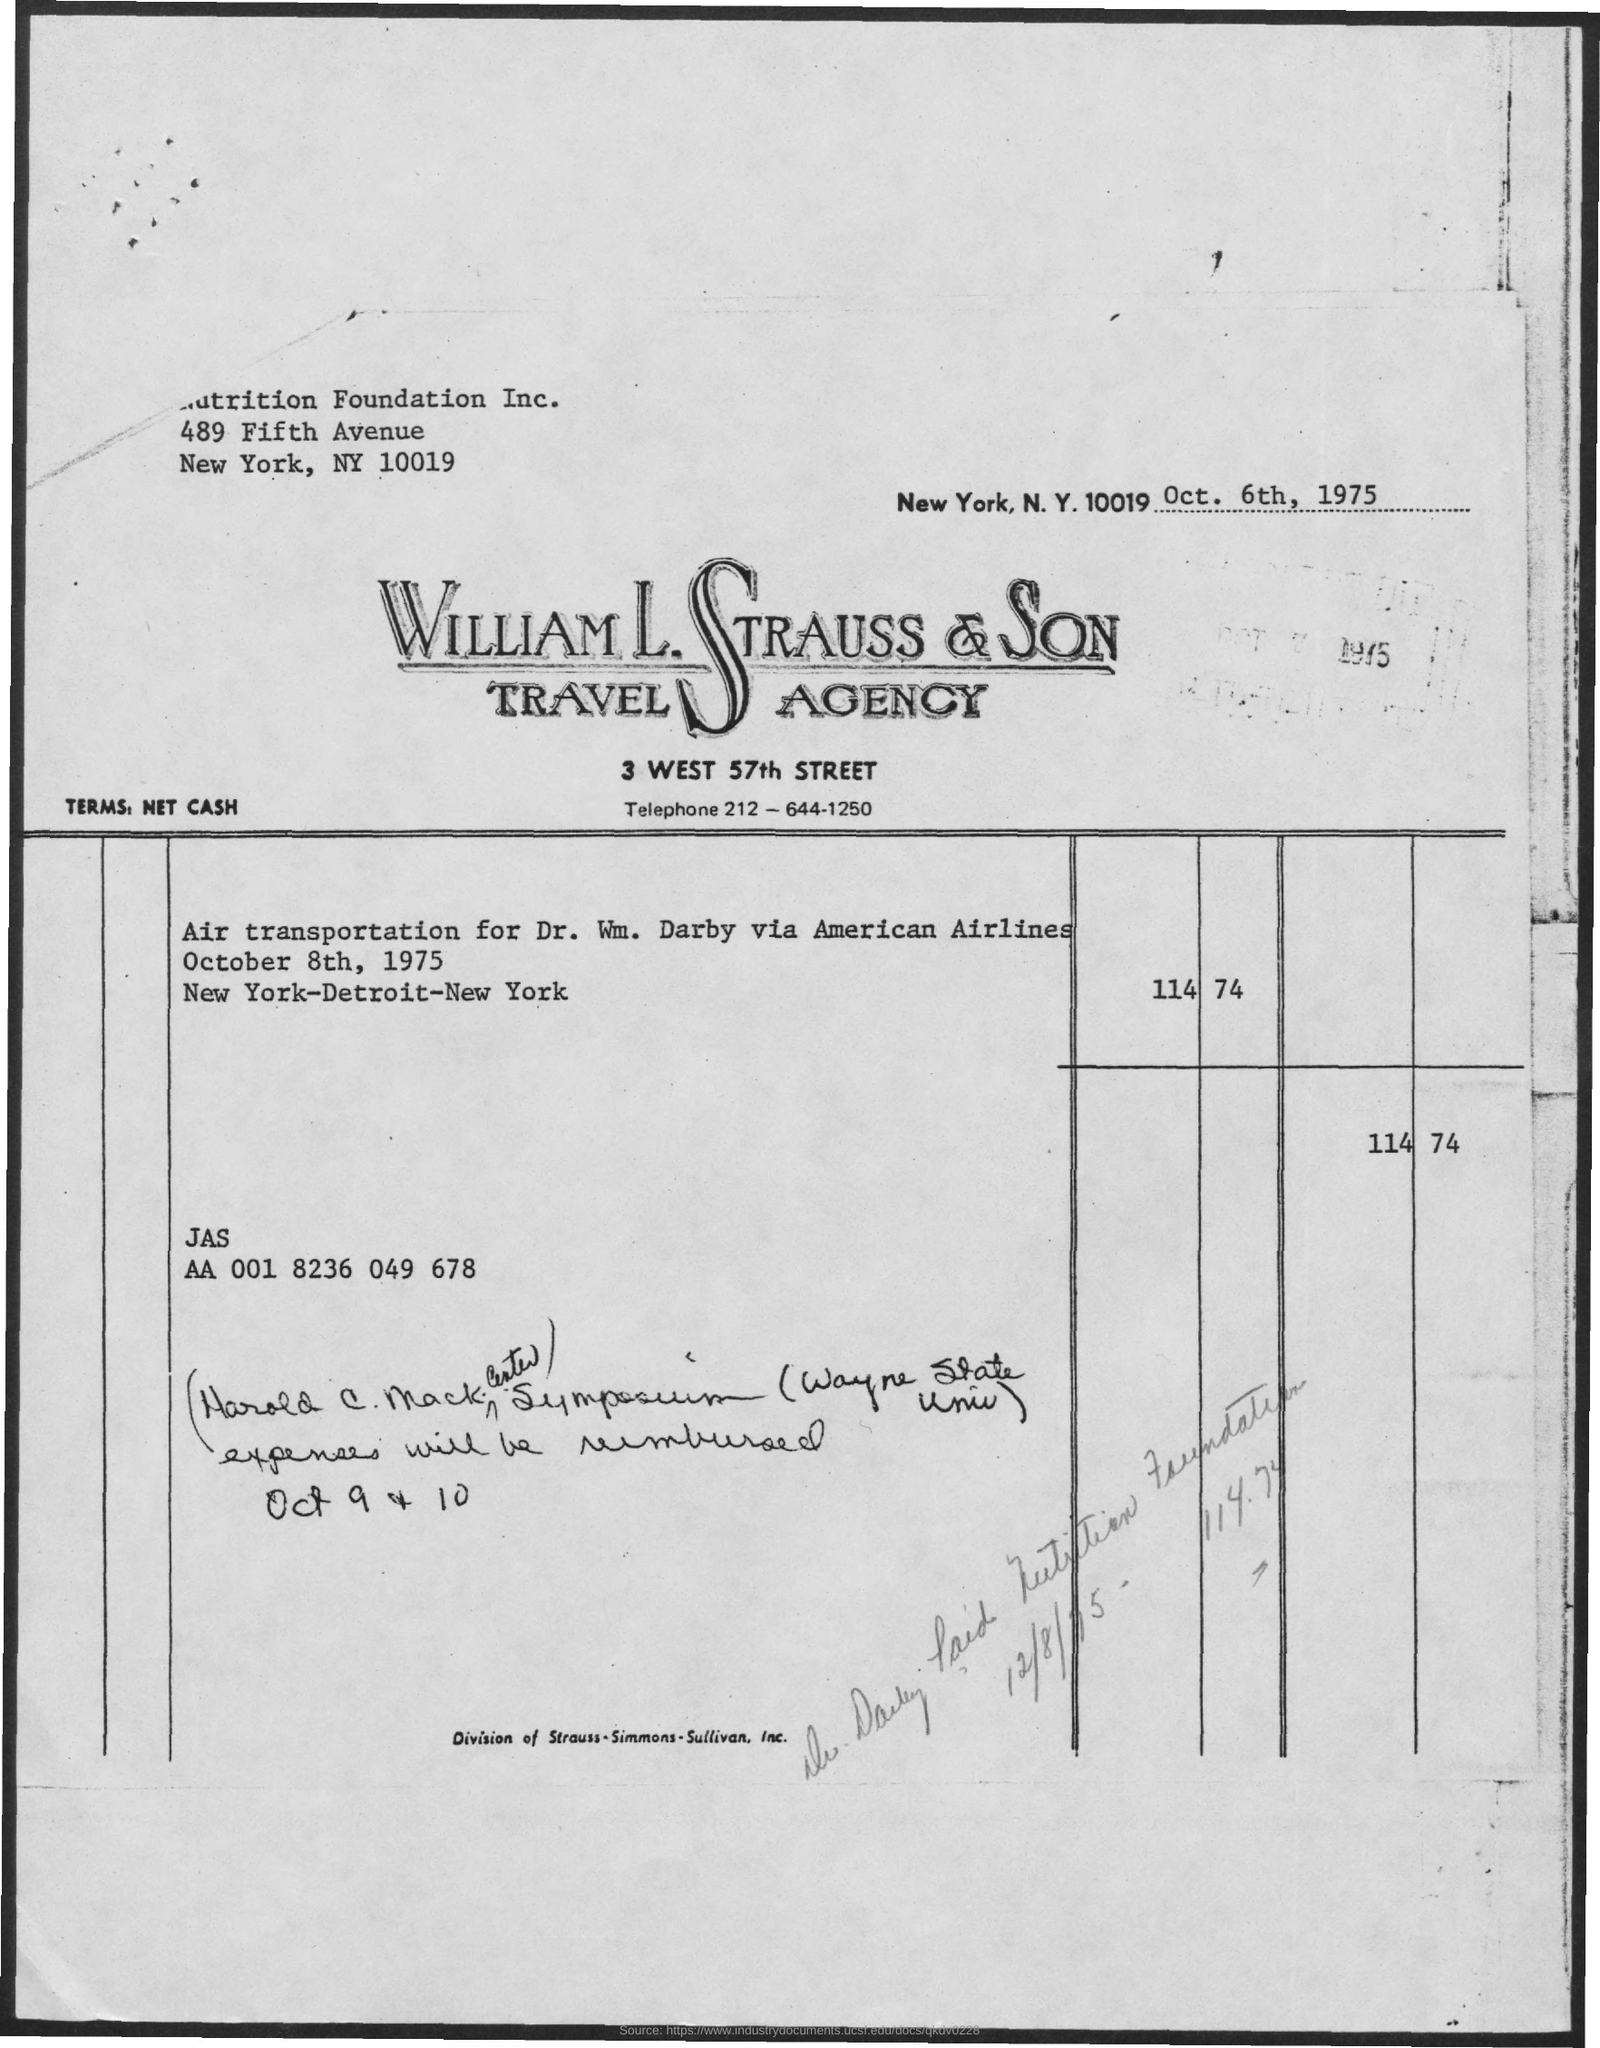Point out several critical features in this image. The zip code for New York City is 10019. 